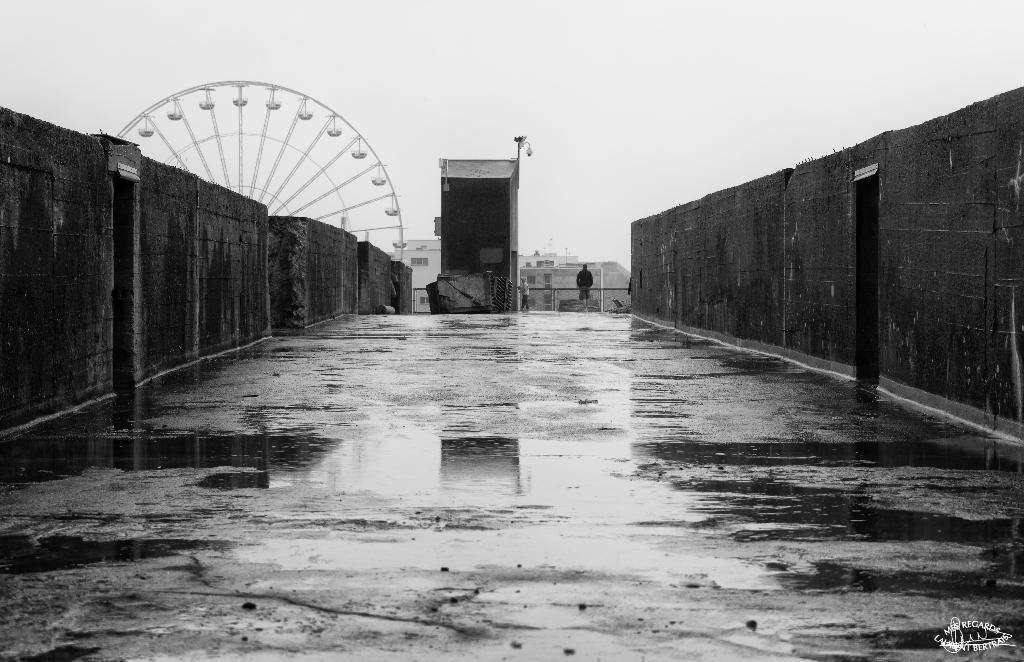Can you describe this image briefly? In this picture we can see the road and there is the wall. And in the background we can see the building. There is person who is standing. And this is the joint wheel. And in the background there is a sky. 